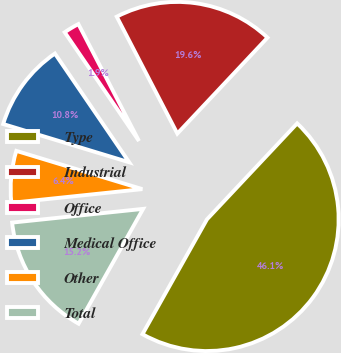<chart> <loc_0><loc_0><loc_500><loc_500><pie_chart><fcel>Type<fcel>Industrial<fcel>Office<fcel>Medical Office<fcel>Other<fcel>Total<nl><fcel>46.13%<fcel>19.61%<fcel>1.93%<fcel>10.77%<fcel>6.35%<fcel>15.19%<nl></chart> 